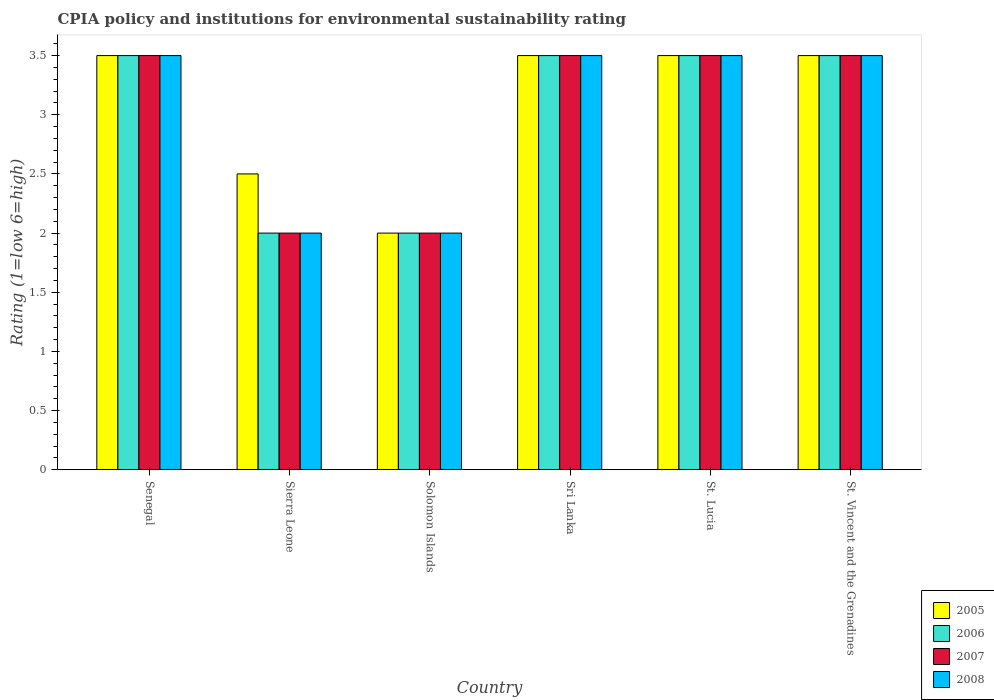How many groups of bars are there?
Your response must be concise. 6. Are the number of bars per tick equal to the number of legend labels?
Offer a terse response. Yes. What is the label of the 2nd group of bars from the left?
Offer a terse response. Sierra Leone. In how many cases, is the number of bars for a given country not equal to the number of legend labels?
Give a very brief answer. 0. Across all countries, what is the minimum CPIA rating in 2008?
Offer a very short reply. 2. In which country was the CPIA rating in 2006 maximum?
Provide a succinct answer. Senegal. In which country was the CPIA rating in 2005 minimum?
Provide a succinct answer. Solomon Islands. What is the difference between the CPIA rating in 2005 in Solomon Islands and the CPIA rating in 2006 in St. Vincent and the Grenadines?
Give a very brief answer. -1.5. What is the average CPIA rating in 2005 per country?
Offer a very short reply. 3.08. What is the difference between the CPIA rating of/in 2007 and CPIA rating of/in 2008 in Sierra Leone?
Provide a succinct answer. 0. In how many countries, is the CPIA rating in 2006 greater than 0.30000000000000004?
Provide a succinct answer. 6. What is the ratio of the CPIA rating in 2008 in Sierra Leone to that in St. Lucia?
Make the answer very short. 0.57. Is the CPIA rating in 2007 in Sri Lanka less than that in St. Vincent and the Grenadines?
Offer a terse response. No. Is the difference between the CPIA rating in 2007 in Sri Lanka and St. Lucia greater than the difference between the CPIA rating in 2008 in Sri Lanka and St. Lucia?
Your answer should be very brief. No. What is the difference between the highest and the lowest CPIA rating in 2005?
Offer a terse response. 1.5. Is the sum of the CPIA rating in 2005 in Senegal and Sierra Leone greater than the maximum CPIA rating in 2008 across all countries?
Offer a very short reply. Yes. Is it the case that in every country, the sum of the CPIA rating in 2005 and CPIA rating in 2007 is greater than the sum of CPIA rating in 2006 and CPIA rating in 2008?
Provide a short and direct response. No. What does the 2nd bar from the right in Sierra Leone represents?
Your answer should be compact. 2007. Is it the case that in every country, the sum of the CPIA rating in 2006 and CPIA rating in 2007 is greater than the CPIA rating in 2005?
Give a very brief answer. Yes. How many bars are there?
Make the answer very short. 24. Are all the bars in the graph horizontal?
Give a very brief answer. No. How many countries are there in the graph?
Your response must be concise. 6. Does the graph contain any zero values?
Offer a very short reply. No. Where does the legend appear in the graph?
Give a very brief answer. Bottom right. What is the title of the graph?
Your answer should be compact. CPIA policy and institutions for environmental sustainability rating. What is the label or title of the X-axis?
Provide a short and direct response. Country. What is the Rating (1=low 6=high) of 2005 in Senegal?
Provide a short and direct response. 3.5. What is the Rating (1=low 6=high) of 2006 in Senegal?
Keep it short and to the point. 3.5. What is the Rating (1=low 6=high) in 2007 in Senegal?
Offer a very short reply. 3.5. What is the Rating (1=low 6=high) in 2005 in Sierra Leone?
Your answer should be very brief. 2.5. What is the Rating (1=low 6=high) in 2006 in Sierra Leone?
Your response must be concise. 2. What is the Rating (1=low 6=high) of 2005 in Solomon Islands?
Your response must be concise. 2. What is the Rating (1=low 6=high) of 2006 in Solomon Islands?
Make the answer very short. 2. What is the Rating (1=low 6=high) in 2007 in Sri Lanka?
Make the answer very short. 3.5. What is the Rating (1=low 6=high) of 2007 in St. Lucia?
Give a very brief answer. 3.5. What is the Rating (1=low 6=high) of 2008 in St. Lucia?
Provide a succinct answer. 3.5. Across all countries, what is the maximum Rating (1=low 6=high) in 2006?
Your answer should be compact. 3.5. Across all countries, what is the maximum Rating (1=low 6=high) of 2007?
Provide a succinct answer. 3.5. Across all countries, what is the maximum Rating (1=low 6=high) of 2008?
Keep it short and to the point. 3.5. Across all countries, what is the minimum Rating (1=low 6=high) in 2008?
Provide a short and direct response. 2. What is the total Rating (1=low 6=high) of 2008 in the graph?
Offer a terse response. 18. What is the difference between the Rating (1=low 6=high) of 2005 in Senegal and that in Sierra Leone?
Your answer should be very brief. 1. What is the difference between the Rating (1=low 6=high) of 2006 in Senegal and that in Solomon Islands?
Provide a succinct answer. 1.5. What is the difference between the Rating (1=low 6=high) in 2008 in Senegal and that in Solomon Islands?
Ensure brevity in your answer.  1.5. What is the difference between the Rating (1=low 6=high) of 2006 in Senegal and that in Sri Lanka?
Provide a short and direct response. 0. What is the difference between the Rating (1=low 6=high) of 2008 in Senegal and that in Sri Lanka?
Keep it short and to the point. 0. What is the difference between the Rating (1=low 6=high) in 2005 in Senegal and that in St. Lucia?
Ensure brevity in your answer.  0. What is the difference between the Rating (1=low 6=high) in 2006 in Senegal and that in St. Lucia?
Offer a terse response. 0. What is the difference between the Rating (1=low 6=high) in 2008 in Senegal and that in St. Lucia?
Provide a succinct answer. 0. What is the difference between the Rating (1=low 6=high) of 2005 in Senegal and that in St. Vincent and the Grenadines?
Provide a short and direct response. 0. What is the difference between the Rating (1=low 6=high) of 2006 in Sierra Leone and that in Solomon Islands?
Your response must be concise. 0. What is the difference between the Rating (1=low 6=high) of 2008 in Sierra Leone and that in Solomon Islands?
Give a very brief answer. 0. What is the difference between the Rating (1=low 6=high) in 2007 in Sierra Leone and that in Sri Lanka?
Your answer should be compact. -1.5. What is the difference between the Rating (1=low 6=high) in 2008 in Sierra Leone and that in Sri Lanka?
Offer a very short reply. -1.5. What is the difference between the Rating (1=low 6=high) in 2008 in Sierra Leone and that in St. Lucia?
Make the answer very short. -1.5. What is the difference between the Rating (1=low 6=high) in 2006 in Sierra Leone and that in St. Vincent and the Grenadines?
Ensure brevity in your answer.  -1.5. What is the difference between the Rating (1=low 6=high) in 2007 in Sierra Leone and that in St. Vincent and the Grenadines?
Your answer should be compact. -1.5. What is the difference between the Rating (1=low 6=high) of 2008 in Sierra Leone and that in St. Vincent and the Grenadines?
Provide a short and direct response. -1.5. What is the difference between the Rating (1=low 6=high) of 2005 in Solomon Islands and that in Sri Lanka?
Offer a terse response. -1.5. What is the difference between the Rating (1=low 6=high) in 2006 in Solomon Islands and that in Sri Lanka?
Provide a succinct answer. -1.5. What is the difference between the Rating (1=low 6=high) of 2006 in Solomon Islands and that in St. Lucia?
Offer a terse response. -1.5. What is the difference between the Rating (1=low 6=high) of 2008 in Solomon Islands and that in St. Lucia?
Your answer should be very brief. -1.5. What is the difference between the Rating (1=low 6=high) in 2006 in Solomon Islands and that in St. Vincent and the Grenadines?
Your response must be concise. -1.5. What is the difference between the Rating (1=low 6=high) of 2008 in Solomon Islands and that in St. Vincent and the Grenadines?
Ensure brevity in your answer.  -1.5. What is the difference between the Rating (1=low 6=high) in 2006 in Sri Lanka and that in St. Lucia?
Your answer should be very brief. 0. What is the difference between the Rating (1=low 6=high) in 2007 in Sri Lanka and that in St. Lucia?
Keep it short and to the point. 0. What is the difference between the Rating (1=low 6=high) in 2008 in Sri Lanka and that in St. Lucia?
Keep it short and to the point. 0. What is the difference between the Rating (1=low 6=high) of 2007 in Sri Lanka and that in St. Vincent and the Grenadines?
Make the answer very short. 0. What is the difference between the Rating (1=low 6=high) in 2008 in Sri Lanka and that in St. Vincent and the Grenadines?
Offer a very short reply. 0. What is the difference between the Rating (1=low 6=high) of 2005 in Senegal and the Rating (1=low 6=high) of 2006 in Sierra Leone?
Provide a succinct answer. 1.5. What is the difference between the Rating (1=low 6=high) of 2005 in Senegal and the Rating (1=low 6=high) of 2008 in Sierra Leone?
Ensure brevity in your answer.  1.5. What is the difference between the Rating (1=low 6=high) in 2006 in Senegal and the Rating (1=low 6=high) in 2007 in Sierra Leone?
Make the answer very short. 1.5. What is the difference between the Rating (1=low 6=high) in 2006 in Senegal and the Rating (1=low 6=high) in 2008 in Sierra Leone?
Provide a succinct answer. 1.5. What is the difference between the Rating (1=low 6=high) in 2005 in Senegal and the Rating (1=low 6=high) in 2006 in Solomon Islands?
Your answer should be compact. 1.5. What is the difference between the Rating (1=low 6=high) in 2005 in Senegal and the Rating (1=low 6=high) in 2008 in Solomon Islands?
Provide a short and direct response. 1.5. What is the difference between the Rating (1=low 6=high) in 2006 in Senegal and the Rating (1=low 6=high) in 2008 in Sri Lanka?
Provide a short and direct response. 0. What is the difference between the Rating (1=low 6=high) in 2007 in Senegal and the Rating (1=low 6=high) in 2008 in Sri Lanka?
Offer a very short reply. 0. What is the difference between the Rating (1=low 6=high) in 2005 in Senegal and the Rating (1=low 6=high) in 2007 in St. Lucia?
Ensure brevity in your answer.  0. What is the difference between the Rating (1=low 6=high) of 2005 in Senegal and the Rating (1=low 6=high) of 2008 in St. Lucia?
Your response must be concise. 0. What is the difference between the Rating (1=low 6=high) in 2006 in Senegal and the Rating (1=low 6=high) in 2007 in St. Lucia?
Offer a terse response. 0. What is the difference between the Rating (1=low 6=high) of 2005 in Senegal and the Rating (1=low 6=high) of 2006 in St. Vincent and the Grenadines?
Your answer should be compact. 0. What is the difference between the Rating (1=low 6=high) in 2005 in Senegal and the Rating (1=low 6=high) in 2007 in St. Vincent and the Grenadines?
Keep it short and to the point. 0. What is the difference between the Rating (1=low 6=high) in 2006 in Senegal and the Rating (1=low 6=high) in 2007 in St. Vincent and the Grenadines?
Make the answer very short. 0. What is the difference between the Rating (1=low 6=high) in 2006 in Senegal and the Rating (1=low 6=high) in 2008 in St. Vincent and the Grenadines?
Your answer should be compact. 0. What is the difference between the Rating (1=low 6=high) in 2007 in Senegal and the Rating (1=low 6=high) in 2008 in St. Vincent and the Grenadines?
Keep it short and to the point. 0. What is the difference between the Rating (1=low 6=high) of 2005 in Sierra Leone and the Rating (1=low 6=high) of 2007 in Solomon Islands?
Ensure brevity in your answer.  0.5. What is the difference between the Rating (1=low 6=high) of 2006 in Sierra Leone and the Rating (1=low 6=high) of 2007 in Solomon Islands?
Your response must be concise. 0. What is the difference between the Rating (1=low 6=high) of 2006 in Sierra Leone and the Rating (1=low 6=high) of 2008 in Solomon Islands?
Make the answer very short. 0. What is the difference between the Rating (1=low 6=high) of 2007 in Sierra Leone and the Rating (1=low 6=high) of 2008 in Solomon Islands?
Your answer should be very brief. 0. What is the difference between the Rating (1=low 6=high) of 2005 in Sierra Leone and the Rating (1=low 6=high) of 2007 in Sri Lanka?
Your response must be concise. -1. What is the difference between the Rating (1=low 6=high) of 2005 in Sierra Leone and the Rating (1=low 6=high) of 2008 in Sri Lanka?
Ensure brevity in your answer.  -1. What is the difference between the Rating (1=low 6=high) in 2006 in Sierra Leone and the Rating (1=low 6=high) in 2007 in Sri Lanka?
Your response must be concise. -1.5. What is the difference between the Rating (1=low 6=high) of 2005 in Sierra Leone and the Rating (1=low 6=high) of 2007 in St. Lucia?
Your answer should be compact. -1. What is the difference between the Rating (1=low 6=high) in 2006 in Sierra Leone and the Rating (1=low 6=high) in 2008 in St. Lucia?
Keep it short and to the point. -1.5. What is the difference between the Rating (1=low 6=high) of 2005 in Sierra Leone and the Rating (1=low 6=high) of 2006 in St. Vincent and the Grenadines?
Give a very brief answer. -1. What is the difference between the Rating (1=low 6=high) of 2006 in Sierra Leone and the Rating (1=low 6=high) of 2007 in St. Vincent and the Grenadines?
Provide a succinct answer. -1.5. What is the difference between the Rating (1=low 6=high) in 2006 in Sierra Leone and the Rating (1=low 6=high) in 2008 in St. Vincent and the Grenadines?
Your answer should be very brief. -1.5. What is the difference between the Rating (1=low 6=high) of 2007 in Sierra Leone and the Rating (1=low 6=high) of 2008 in St. Vincent and the Grenadines?
Offer a terse response. -1.5. What is the difference between the Rating (1=low 6=high) of 2006 in Solomon Islands and the Rating (1=low 6=high) of 2007 in Sri Lanka?
Provide a succinct answer. -1.5. What is the difference between the Rating (1=low 6=high) of 2006 in Solomon Islands and the Rating (1=low 6=high) of 2008 in Sri Lanka?
Provide a short and direct response. -1.5. What is the difference between the Rating (1=low 6=high) in 2007 in Solomon Islands and the Rating (1=low 6=high) in 2008 in Sri Lanka?
Make the answer very short. -1.5. What is the difference between the Rating (1=low 6=high) of 2005 in Solomon Islands and the Rating (1=low 6=high) of 2008 in St. Lucia?
Your answer should be very brief. -1.5. What is the difference between the Rating (1=low 6=high) of 2006 in Solomon Islands and the Rating (1=low 6=high) of 2008 in St. Lucia?
Provide a succinct answer. -1.5. What is the difference between the Rating (1=low 6=high) in 2005 in Solomon Islands and the Rating (1=low 6=high) in 2007 in St. Vincent and the Grenadines?
Keep it short and to the point. -1.5. What is the difference between the Rating (1=low 6=high) in 2006 in Solomon Islands and the Rating (1=low 6=high) in 2007 in St. Vincent and the Grenadines?
Your answer should be compact. -1.5. What is the difference between the Rating (1=low 6=high) in 2006 in Solomon Islands and the Rating (1=low 6=high) in 2008 in St. Vincent and the Grenadines?
Ensure brevity in your answer.  -1.5. What is the difference between the Rating (1=low 6=high) of 2007 in Solomon Islands and the Rating (1=low 6=high) of 2008 in St. Vincent and the Grenadines?
Keep it short and to the point. -1.5. What is the difference between the Rating (1=low 6=high) in 2006 in Sri Lanka and the Rating (1=low 6=high) in 2008 in St. Lucia?
Your answer should be very brief. 0. What is the difference between the Rating (1=low 6=high) in 2007 in Sri Lanka and the Rating (1=low 6=high) in 2008 in St. Lucia?
Offer a very short reply. 0. What is the difference between the Rating (1=low 6=high) in 2005 in Sri Lanka and the Rating (1=low 6=high) in 2007 in St. Vincent and the Grenadines?
Ensure brevity in your answer.  0. What is the difference between the Rating (1=low 6=high) in 2006 in Sri Lanka and the Rating (1=low 6=high) in 2007 in St. Vincent and the Grenadines?
Ensure brevity in your answer.  0. What is the difference between the Rating (1=low 6=high) of 2006 in Sri Lanka and the Rating (1=low 6=high) of 2008 in St. Vincent and the Grenadines?
Keep it short and to the point. 0. What is the difference between the Rating (1=low 6=high) of 2005 in St. Lucia and the Rating (1=low 6=high) of 2006 in St. Vincent and the Grenadines?
Offer a very short reply. 0. What is the average Rating (1=low 6=high) in 2005 per country?
Your response must be concise. 3.08. What is the average Rating (1=low 6=high) in 2006 per country?
Give a very brief answer. 3. What is the average Rating (1=low 6=high) in 2007 per country?
Keep it short and to the point. 3. What is the average Rating (1=low 6=high) in 2008 per country?
Keep it short and to the point. 3. What is the difference between the Rating (1=low 6=high) of 2005 and Rating (1=low 6=high) of 2007 in Senegal?
Offer a terse response. 0. What is the difference between the Rating (1=low 6=high) in 2005 and Rating (1=low 6=high) in 2008 in Senegal?
Provide a succinct answer. 0. What is the difference between the Rating (1=low 6=high) of 2005 and Rating (1=low 6=high) of 2007 in Sierra Leone?
Provide a succinct answer. 0.5. What is the difference between the Rating (1=low 6=high) of 2006 and Rating (1=low 6=high) of 2008 in Sierra Leone?
Give a very brief answer. 0. What is the difference between the Rating (1=low 6=high) in 2005 and Rating (1=low 6=high) in 2008 in Solomon Islands?
Keep it short and to the point. 0. What is the difference between the Rating (1=low 6=high) of 2005 and Rating (1=low 6=high) of 2007 in Sri Lanka?
Provide a short and direct response. 0. What is the difference between the Rating (1=low 6=high) of 2005 and Rating (1=low 6=high) of 2008 in Sri Lanka?
Offer a very short reply. 0. What is the difference between the Rating (1=low 6=high) in 2006 and Rating (1=low 6=high) in 2008 in Sri Lanka?
Provide a succinct answer. 0. What is the difference between the Rating (1=low 6=high) of 2005 and Rating (1=low 6=high) of 2006 in St. Lucia?
Offer a very short reply. 0. What is the difference between the Rating (1=low 6=high) of 2005 and Rating (1=low 6=high) of 2007 in St. Lucia?
Keep it short and to the point. 0. What is the difference between the Rating (1=low 6=high) in 2007 and Rating (1=low 6=high) in 2008 in St. Lucia?
Keep it short and to the point. 0. What is the difference between the Rating (1=low 6=high) of 2005 and Rating (1=low 6=high) of 2007 in St. Vincent and the Grenadines?
Give a very brief answer. 0. What is the difference between the Rating (1=low 6=high) of 2006 and Rating (1=low 6=high) of 2008 in St. Vincent and the Grenadines?
Ensure brevity in your answer.  0. What is the ratio of the Rating (1=low 6=high) of 2006 in Senegal to that in Sierra Leone?
Give a very brief answer. 1.75. What is the ratio of the Rating (1=low 6=high) of 2008 in Senegal to that in Sierra Leone?
Offer a terse response. 1.75. What is the ratio of the Rating (1=low 6=high) of 2005 in Senegal to that in Solomon Islands?
Your answer should be compact. 1.75. What is the ratio of the Rating (1=low 6=high) in 2006 in Senegal to that in Solomon Islands?
Your response must be concise. 1.75. What is the ratio of the Rating (1=low 6=high) in 2005 in Senegal to that in Sri Lanka?
Offer a terse response. 1. What is the ratio of the Rating (1=low 6=high) of 2007 in Senegal to that in Sri Lanka?
Offer a terse response. 1. What is the ratio of the Rating (1=low 6=high) in 2006 in Senegal to that in St. Lucia?
Make the answer very short. 1. What is the ratio of the Rating (1=low 6=high) of 2008 in Senegal to that in St. Lucia?
Give a very brief answer. 1. What is the ratio of the Rating (1=low 6=high) in 2006 in Senegal to that in St. Vincent and the Grenadines?
Provide a short and direct response. 1. What is the ratio of the Rating (1=low 6=high) in 2007 in Senegal to that in St. Vincent and the Grenadines?
Your answer should be compact. 1. What is the ratio of the Rating (1=low 6=high) of 2008 in Senegal to that in St. Vincent and the Grenadines?
Provide a short and direct response. 1. What is the ratio of the Rating (1=low 6=high) of 2006 in Sierra Leone to that in Solomon Islands?
Ensure brevity in your answer.  1. What is the ratio of the Rating (1=low 6=high) in 2005 in Sierra Leone to that in Sri Lanka?
Make the answer very short. 0.71. What is the ratio of the Rating (1=low 6=high) of 2007 in Sierra Leone to that in Sri Lanka?
Make the answer very short. 0.57. What is the ratio of the Rating (1=low 6=high) in 2008 in Sierra Leone to that in Sri Lanka?
Keep it short and to the point. 0.57. What is the ratio of the Rating (1=low 6=high) of 2005 in Sierra Leone to that in St. Lucia?
Offer a very short reply. 0.71. What is the ratio of the Rating (1=low 6=high) in 2008 in Sierra Leone to that in St. Lucia?
Give a very brief answer. 0.57. What is the ratio of the Rating (1=low 6=high) in 2006 in Sierra Leone to that in St. Vincent and the Grenadines?
Your answer should be very brief. 0.57. What is the ratio of the Rating (1=low 6=high) in 2007 in Sierra Leone to that in St. Vincent and the Grenadines?
Your answer should be compact. 0.57. What is the ratio of the Rating (1=low 6=high) of 2008 in Solomon Islands to that in Sri Lanka?
Make the answer very short. 0.57. What is the ratio of the Rating (1=low 6=high) in 2008 in Solomon Islands to that in St. Lucia?
Offer a very short reply. 0.57. What is the ratio of the Rating (1=low 6=high) in 2008 in Solomon Islands to that in St. Vincent and the Grenadines?
Your answer should be very brief. 0.57. What is the ratio of the Rating (1=low 6=high) in 2008 in Sri Lanka to that in St. Lucia?
Provide a short and direct response. 1. What is the ratio of the Rating (1=low 6=high) in 2005 in Sri Lanka to that in St. Vincent and the Grenadines?
Offer a terse response. 1. What is the ratio of the Rating (1=low 6=high) of 2006 in Sri Lanka to that in St. Vincent and the Grenadines?
Your answer should be compact. 1. What is the ratio of the Rating (1=low 6=high) in 2005 in St. Lucia to that in St. Vincent and the Grenadines?
Keep it short and to the point. 1. What is the ratio of the Rating (1=low 6=high) of 2006 in St. Lucia to that in St. Vincent and the Grenadines?
Keep it short and to the point. 1. What is the ratio of the Rating (1=low 6=high) in 2008 in St. Lucia to that in St. Vincent and the Grenadines?
Keep it short and to the point. 1. What is the difference between the highest and the second highest Rating (1=low 6=high) in 2007?
Provide a succinct answer. 0. What is the difference between the highest and the lowest Rating (1=low 6=high) of 2006?
Your answer should be very brief. 1.5. What is the difference between the highest and the lowest Rating (1=low 6=high) in 2008?
Your response must be concise. 1.5. 